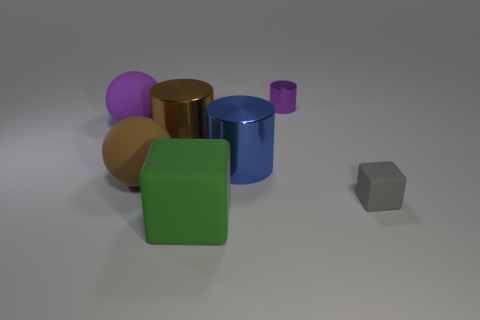There is a object that is the same color as the small cylinder; what is its material?
Make the answer very short. Rubber. Is the cylinder that is behind the large purple matte thing made of the same material as the thing that is in front of the gray matte cube?
Provide a short and direct response. No. Is the number of big objects greater than the number of objects?
Give a very brief answer. No. There is a thing to the left of the brown sphere that is to the left of the large cylinder that is left of the blue thing; what color is it?
Provide a short and direct response. Purple. Is the color of the metal object that is right of the large blue thing the same as the rubber sphere behind the big brown matte object?
Keep it short and to the point. Yes. What number of green things are in front of the brown object behind the big brown matte ball?
Your response must be concise. 1. Is there a brown matte ball?
Provide a short and direct response. Yes. How many other objects are the same color as the large cube?
Provide a short and direct response. 0. Are there fewer gray rubber objects than green cylinders?
Offer a terse response. No. What shape is the rubber thing that is right of the metal cylinder behind the purple rubber thing?
Ensure brevity in your answer.  Cube. 